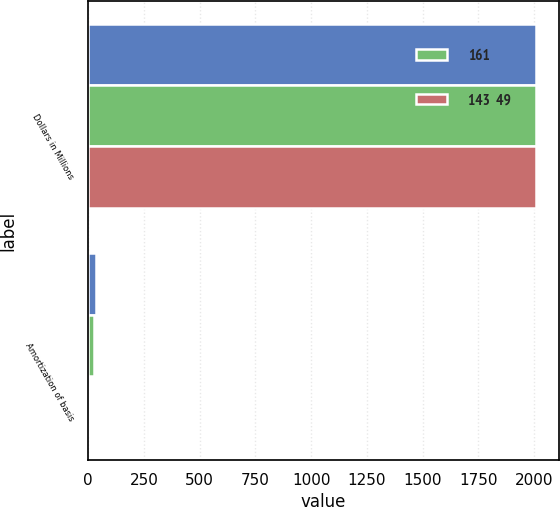<chart> <loc_0><loc_0><loc_500><loc_500><stacked_bar_chart><ecel><fcel>Dollars in Millions<fcel>Amortization of basis<nl><fcel>nan<fcel>2010<fcel>33<nl><fcel>161<fcel>2009<fcel>25<nl><fcel>143  49<fcel>2008<fcel>1<nl></chart> 